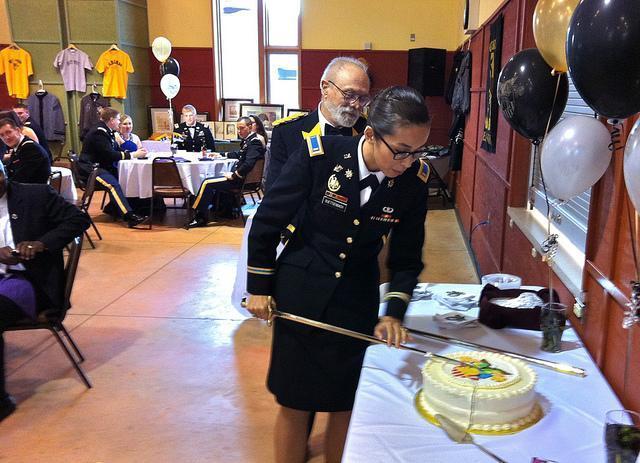How many balloons are on the back table?
Give a very brief answer. 3. How many people can be seen?
Give a very brief answer. 6. 